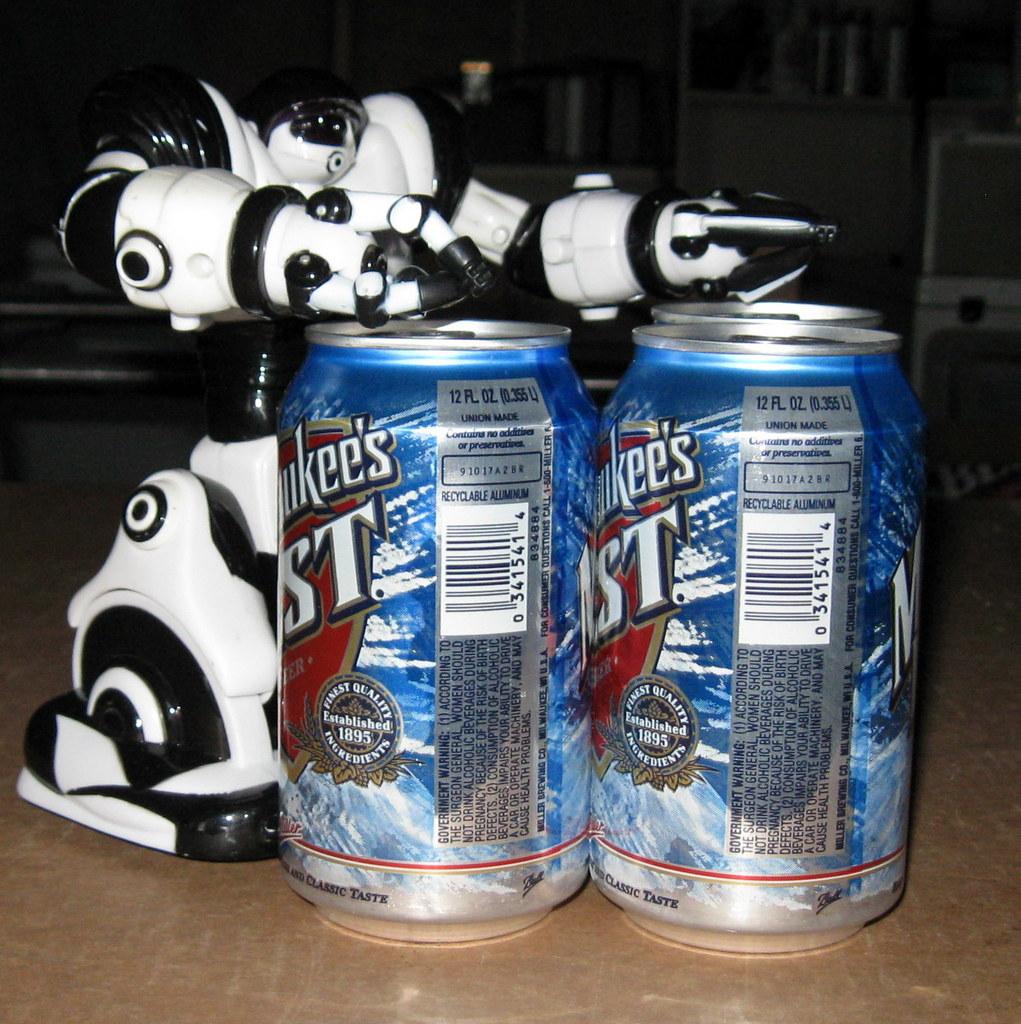When was this beer established?
Your answer should be compact. 1895. How many ounces?
Give a very brief answer. 12. 